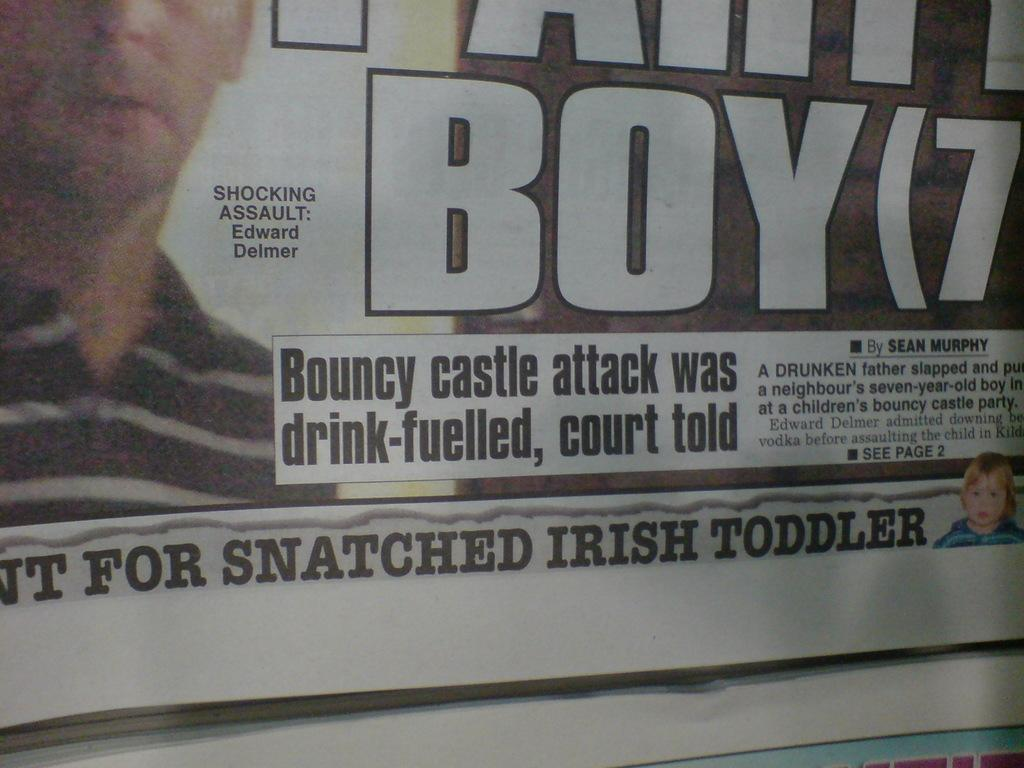What is present on the paper in the image? There is text and images on the paper in the image. Can you describe the text on the paper? Unfortunately, the specific content of the text cannot be determined from the image alone. What type of images are on the paper? The nature of the images on the paper cannot be determined from the image alone. How many cows are depicted in the images on the paper? There is no information about cows or any other specific images on the paper in the image. 